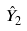Convert formula to latex. <formula><loc_0><loc_0><loc_500><loc_500>\hat { Y } _ { 2 }</formula> 